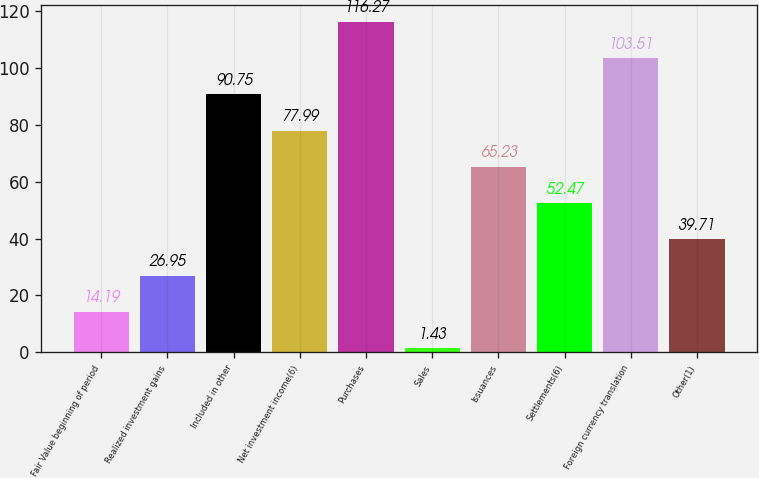Convert chart. <chart><loc_0><loc_0><loc_500><loc_500><bar_chart><fcel>Fair Value beginning of period<fcel>Realized investment gains<fcel>Included in other<fcel>Net investment income(6)<fcel>Purchases<fcel>Sales<fcel>Issuances<fcel>Settlements(6)<fcel>Foreign currency translation<fcel>Other(1)<nl><fcel>14.19<fcel>26.95<fcel>90.75<fcel>77.99<fcel>116.27<fcel>1.43<fcel>65.23<fcel>52.47<fcel>103.51<fcel>39.71<nl></chart> 